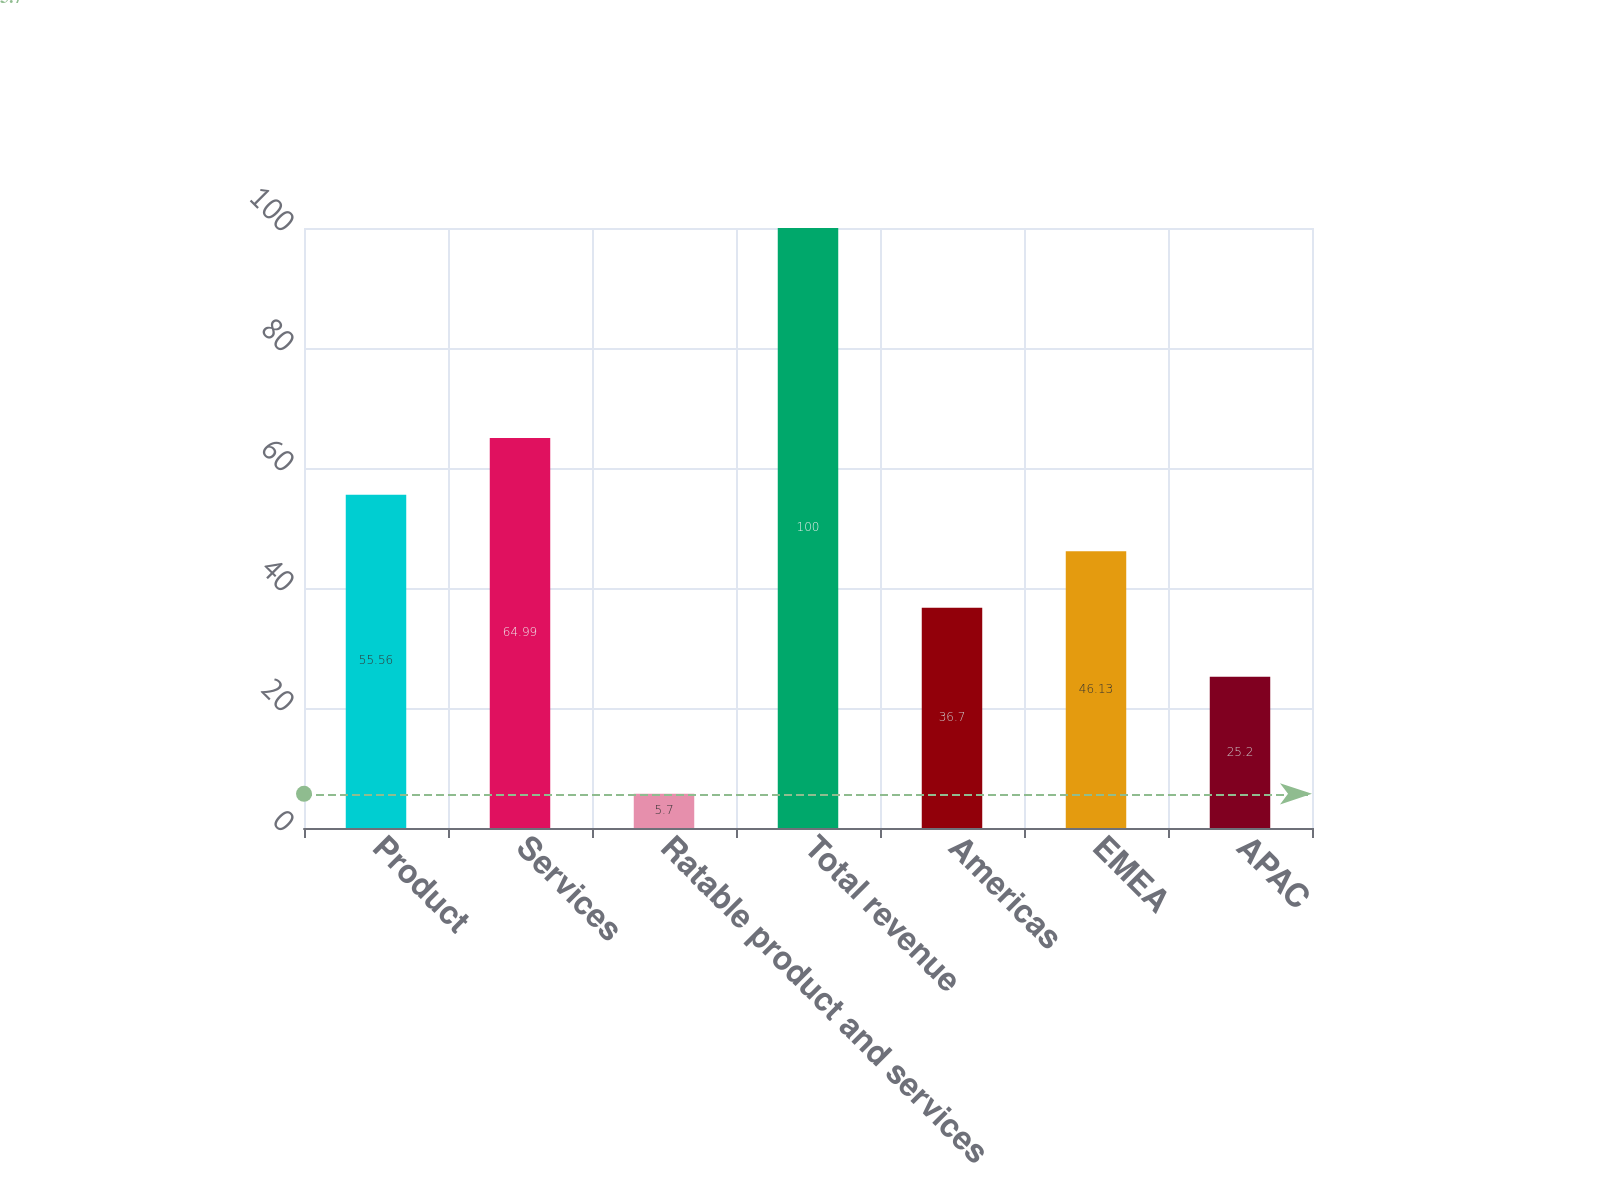Convert chart to OTSL. <chart><loc_0><loc_0><loc_500><loc_500><bar_chart><fcel>Product<fcel>Services<fcel>Ratable product and services<fcel>Total revenue<fcel>Americas<fcel>EMEA<fcel>APAC<nl><fcel>55.56<fcel>64.99<fcel>5.7<fcel>100<fcel>36.7<fcel>46.13<fcel>25.2<nl></chart> 